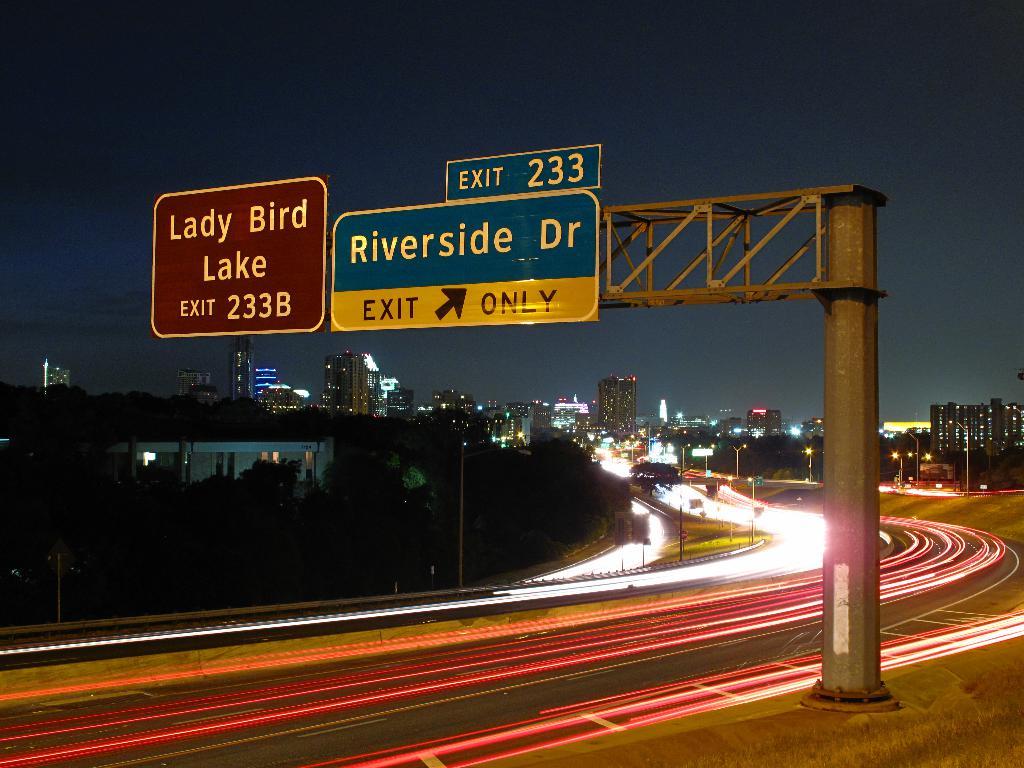What is at exit 233b?
Your response must be concise. Lady bird lake. 